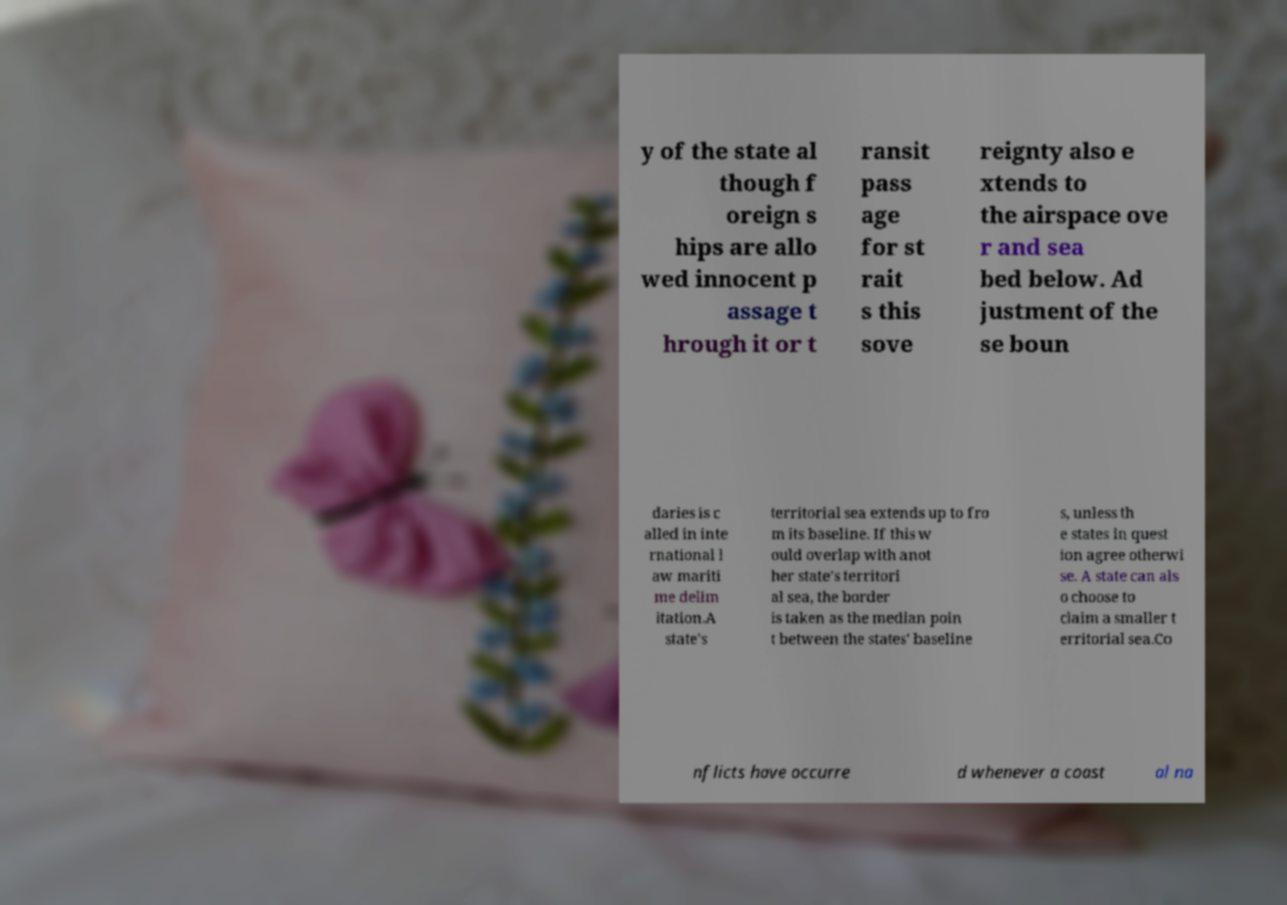For documentation purposes, I need the text within this image transcribed. Could you provide that? y of the state al though f oreign s hips are allo wed innocent p assage t hrough it or t ransit pass age for st rait s this sove reignty also e xtends to the airspace ove r and sea bed below. Ad justment of the se boun daries is c alled in inte rnational l aw mariti me delim itation.A state's territorial sea extends up to fro m its baseline. If this w ould overlap with anot her state's territori al sea, the border is taken as the median poin t between the states' baseline s, unless th e states in quest ion agree otherwi se. A state can als o choose to claim a smaller t erritorial sea.Co nflicts have occurre d whenever a coast al na 